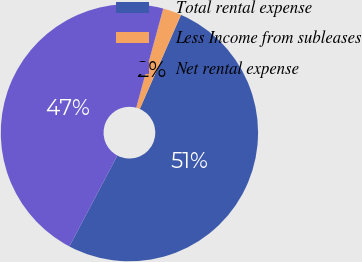Convert chart. <chart><loc_0><loc_0><loc_500><loc_500><pie_chart><fcel>Total rental expense<fcel>Less Income from subleases<fcel>Net rental expense<nl><fcel>51.16%<fcel>2.33%<fcel>46.51%<nl></chart> 